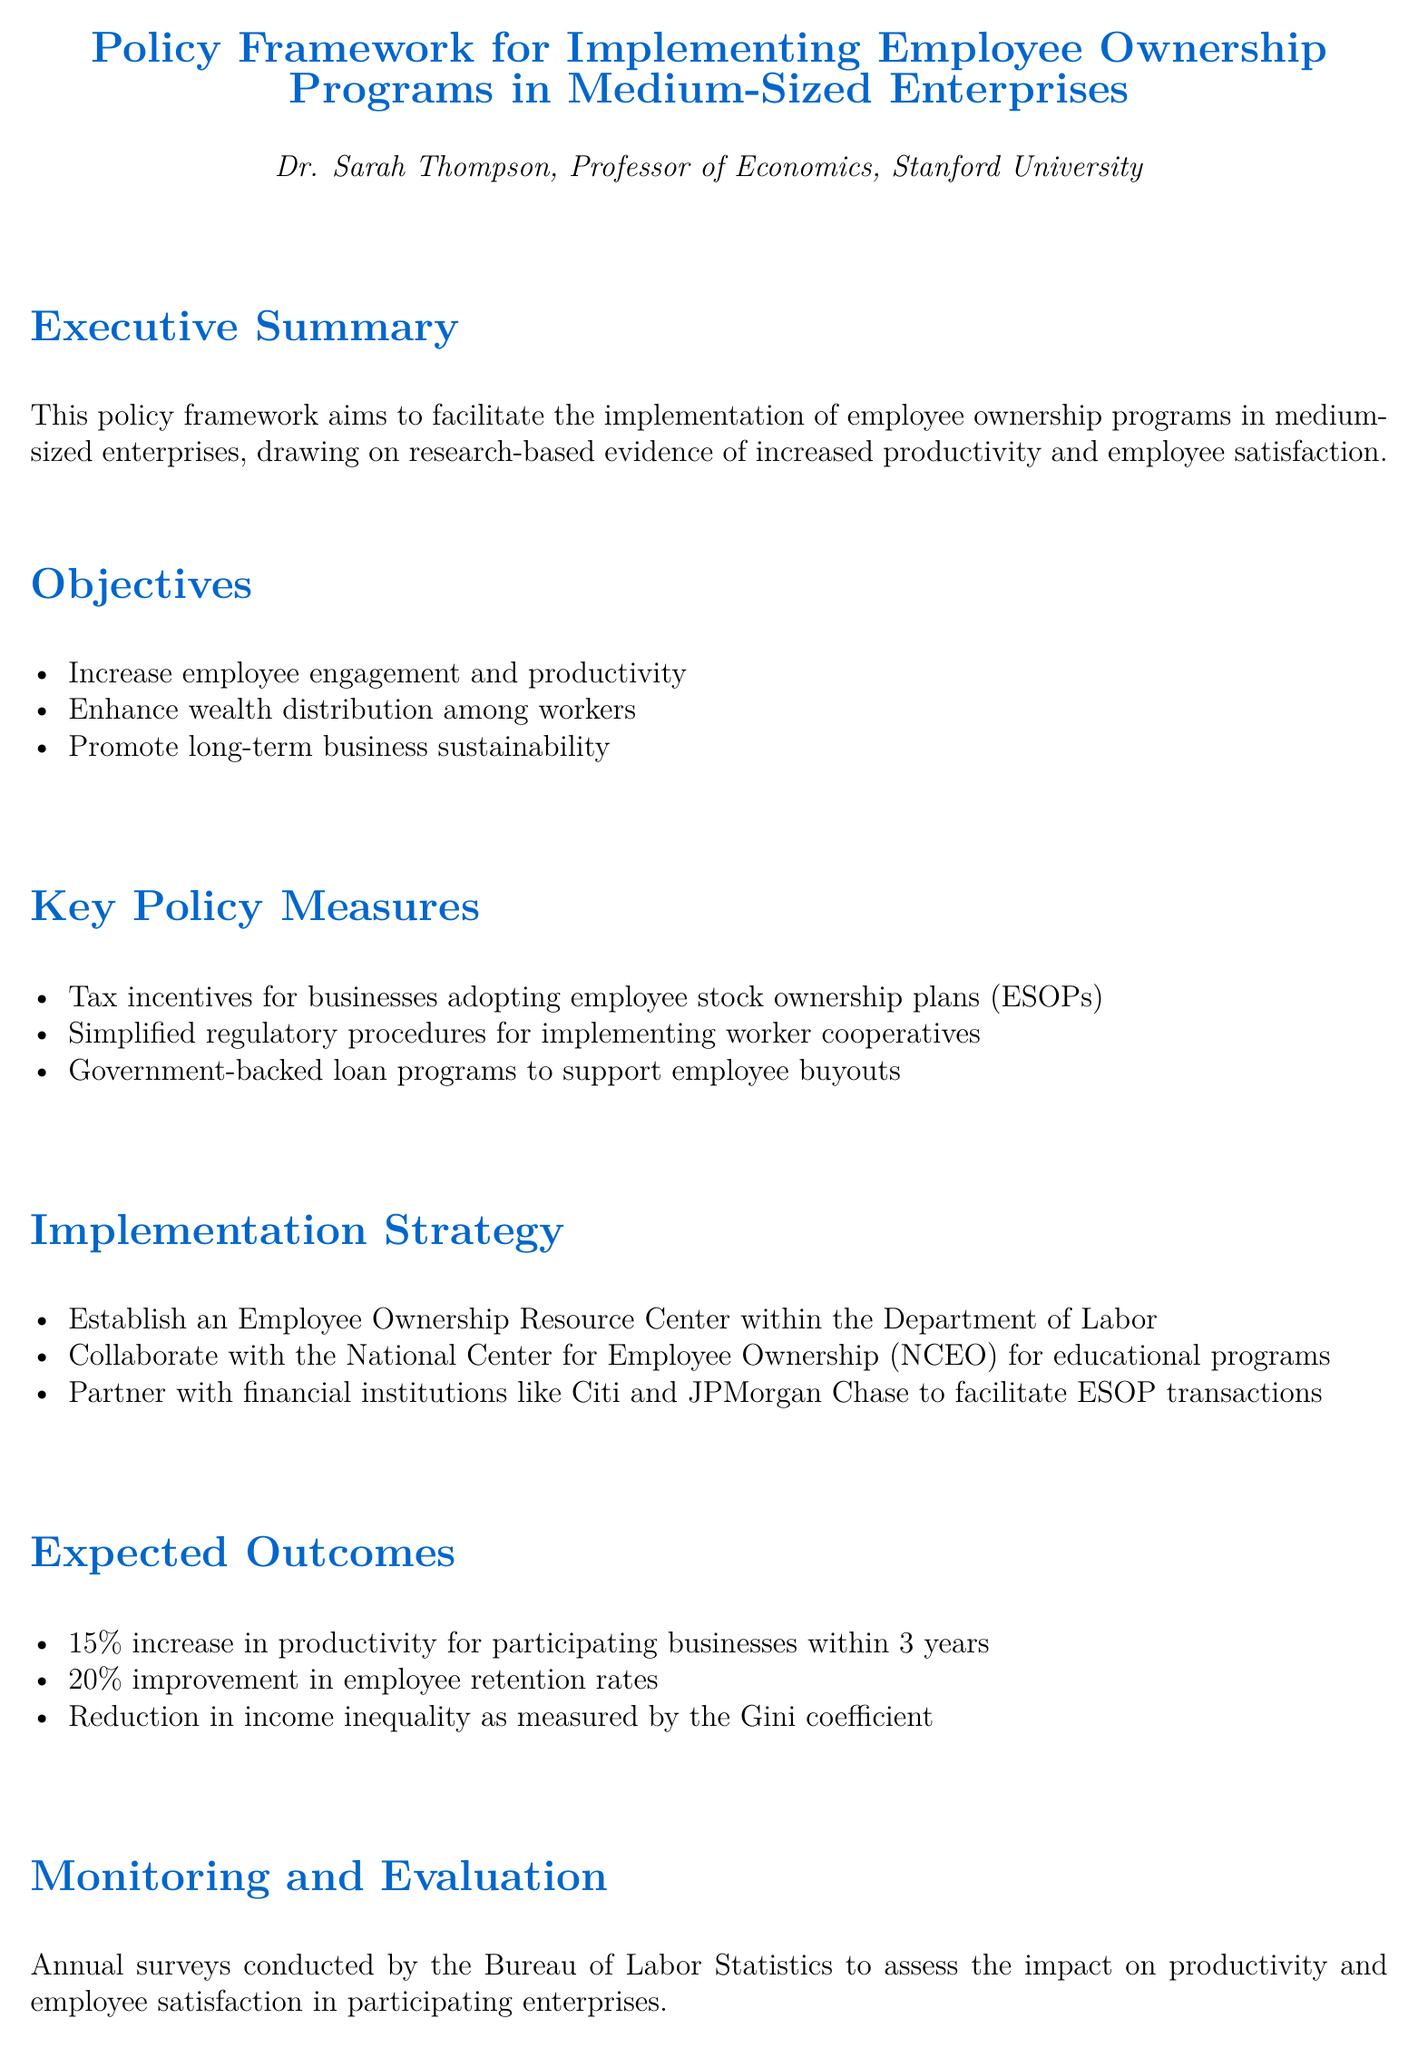What is the primary aim of this policy framework? The primary aim, as stated in the executive summary, is to facilitate the implementation of employee ownership programs in medium-sized enterprises.
Answer: To facilitate the implementation of employee ownership programs What percentage increase in productivity is expected within 3 years? The document specifies that there is an expected 15% increase in productivity for participating businesses within 3 years.
Answer: 15% What are the three key objectives listed in the document? The document outlines three key objectives which are to increase employee engagement and productivity, enhance wealth distribution among workers, and promote long-term business sustainability.
Answer: Increase employee engagement and productivity, enhance wealth distribution among workers, promote long-term business sustainability Which organization is mentioned for collaboration in educational programs? The document mentions the National Center for Employee Ownership (NCEO) for collaboration on educational programs.
Answer: National Center for Employee Ownership (NCEO) What is proposed as a measure to support employee buyouts? The policy framework suggests government-backed loan programs to support employee buyouts.
Answer: Government-backed loan programs What is the anticipated improvement in employee retention rates? The document indicates an expected 20% improvement in employee retention rates.
Answer: 20% Which institution is responsible for monitoring and evaluation? The Bureau of Labor Statistics is tasked with conducting annual surveys to assess impact.
Answer: Bureau of Labor Statistics What specific resource center is proposed for employee ownership? The proposal includes establishing an Employee Ownership Resource Center within the Department of Labor.
Answer: Employee Ownership Resource Center 